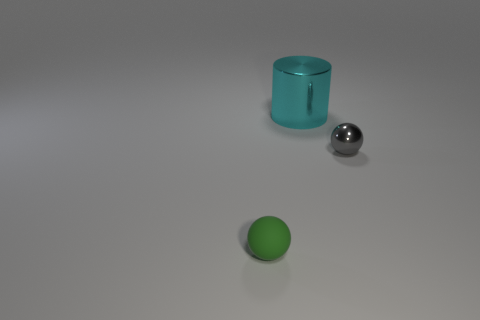Are there any signs of motion or life in the image? The image captures a static scene with no apparent motion or signs of life. Each object is perfectly still, and the absence of dynamic elements such as fluid, animals, or human presence conveys a sense of quiet and inanimate calmness. 